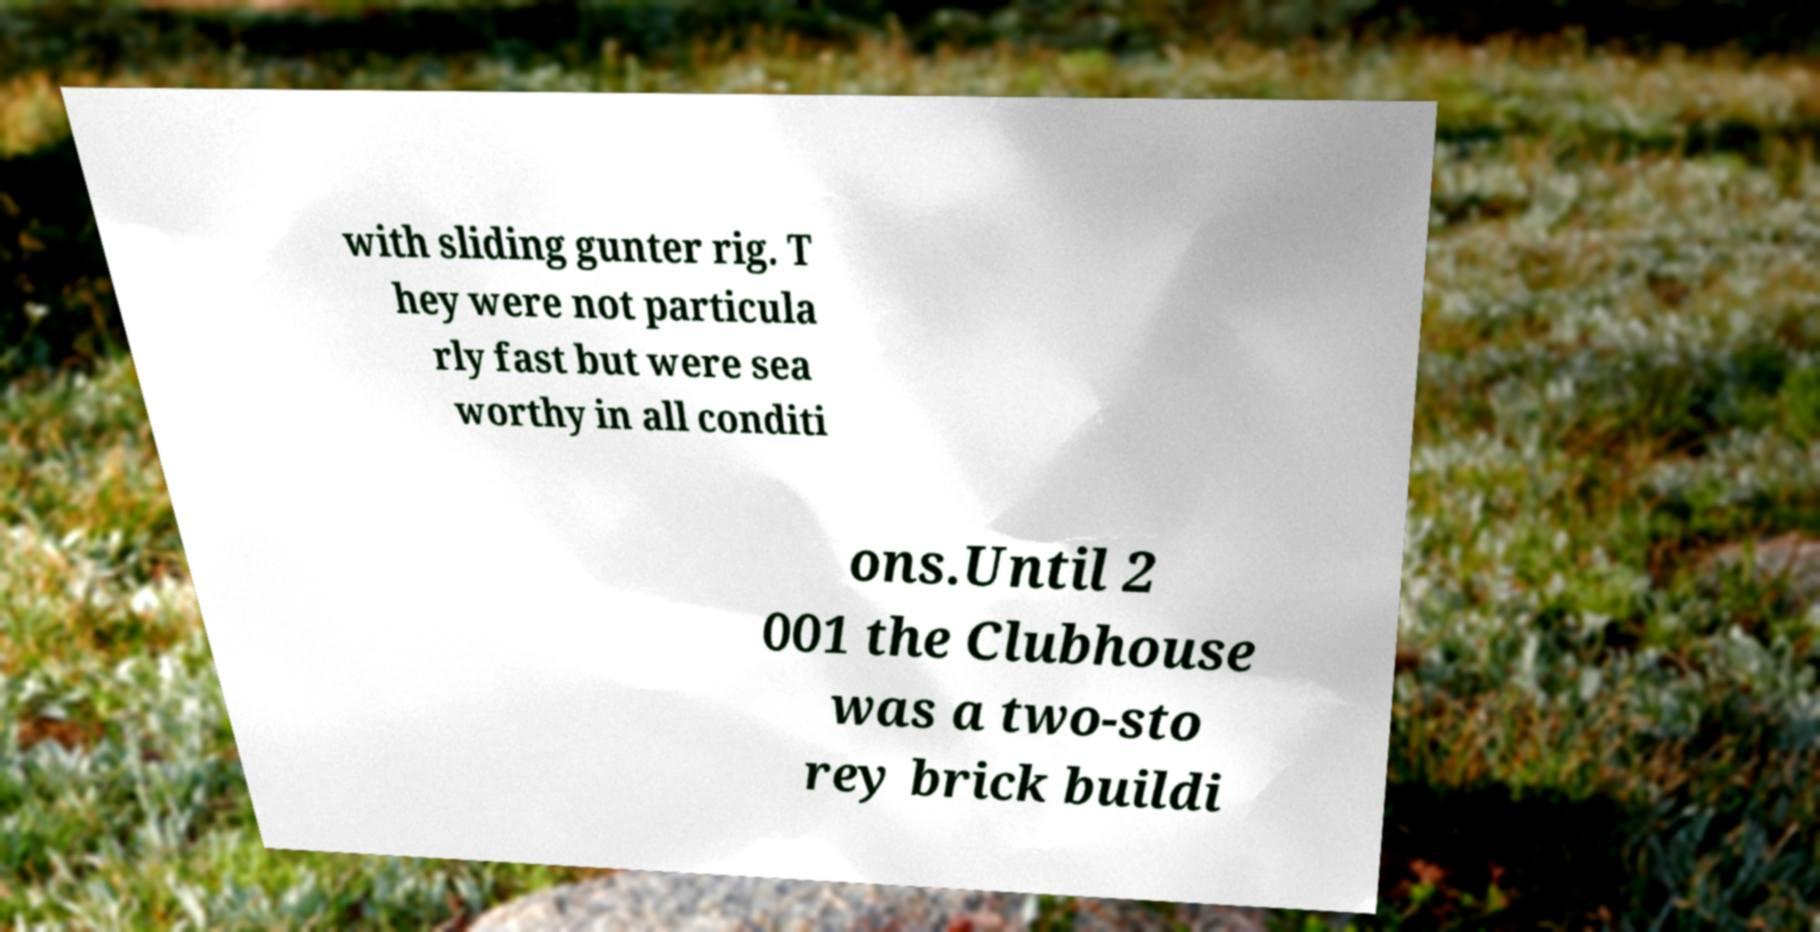I need the written content from this picture converted into text. Can you do that? with sliding gunter rig. T hey were not particula rly fast but were sea worthy in all conditi ons.Until 2 001 the Clubhouse was a two-sto rey brick buildi 